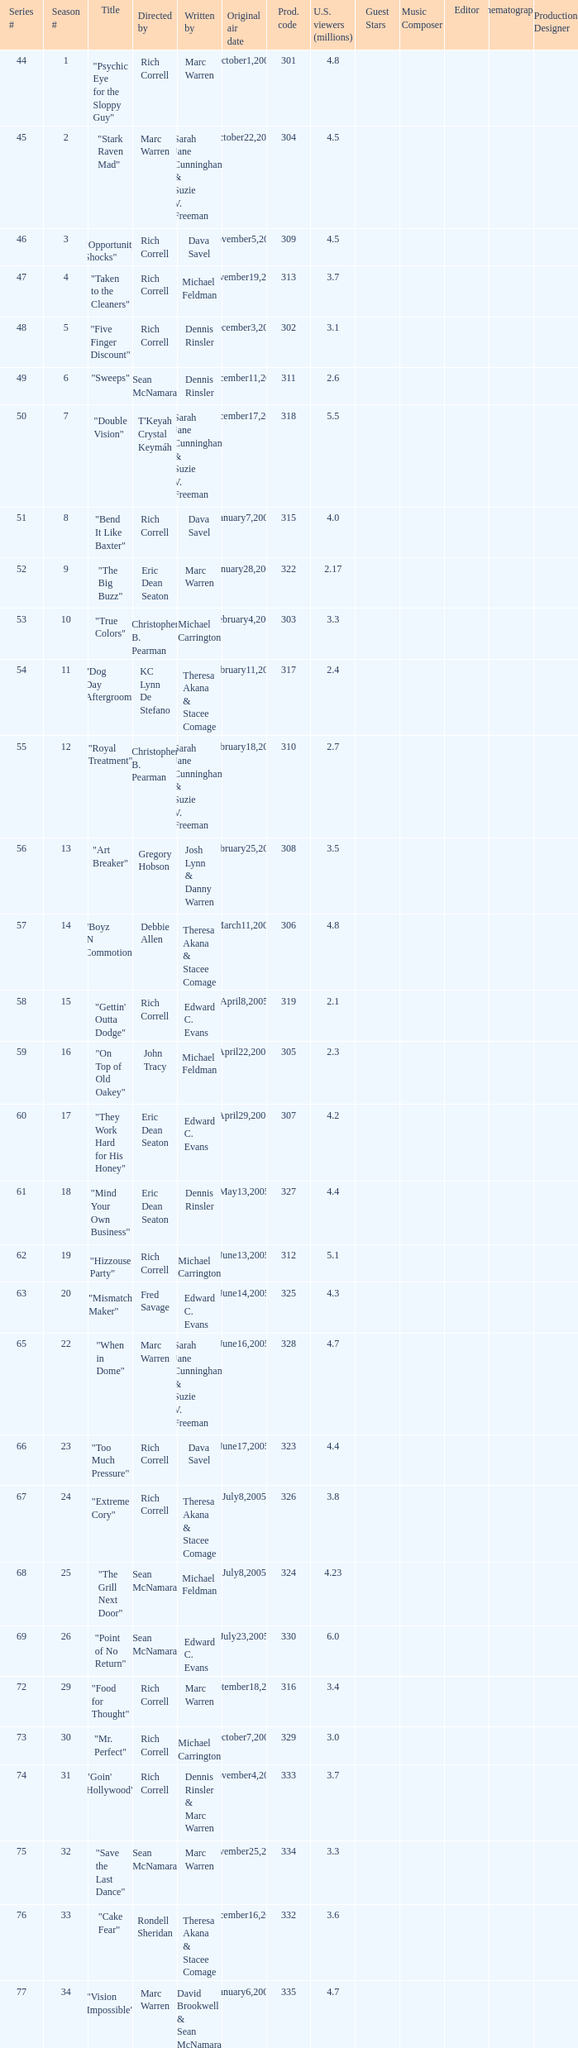What number episode in the season had a production code of 334? 32.0. 